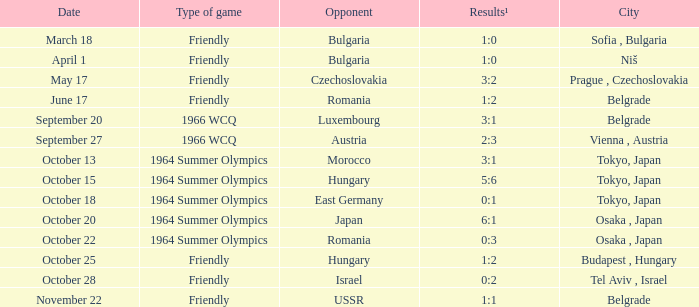Which city experienced a happening on the 13th of october? Tokyo, Japan. 